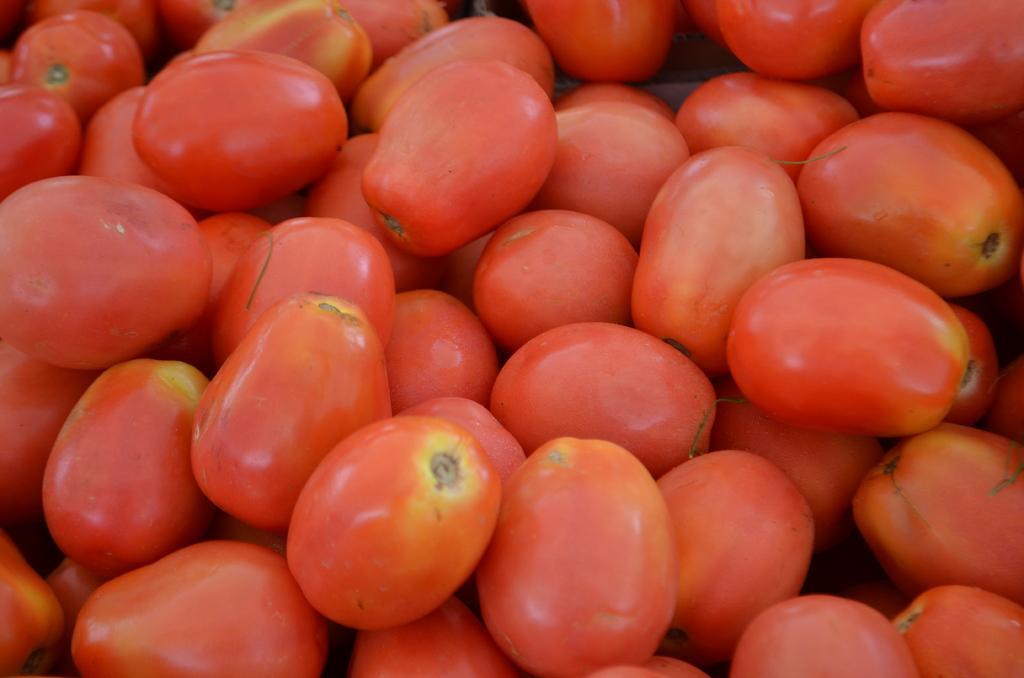Can you describe this image briefly? In this image I can see few tomatoes. These are in red color. 